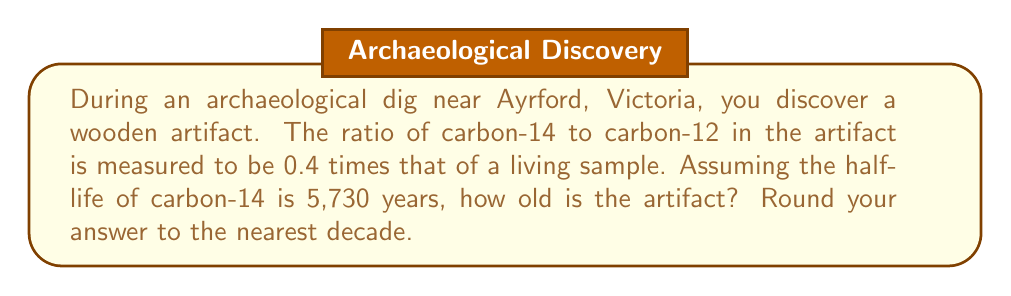Show me your answer to this math problem. Let's approach this step-by-step using the radiocarbon dating equation:

1) The equation for radiocarbon dating is:

   $$\frac{N}{N_0} = e^{-\lambda t}$$

   Where:
   $N$ = current amount of C-14
   $N_0$ = original amount of C-14
   $\lambda$ = decay constant
   $t$ = time elapsed

2) We're given that $\frac{N}{N_0} = 0.4$

3) We need to find $\lambda$. The half-life formula is:

   $$t_{1/2} = \frac{\ln(2)}{\lambda}$$

4) Rearranging for $\lambda$:

   $$\lambda = \frac{\ln(2)}{t_{1/2}} = \frac{\ln(2)}{5730} \approx 0.000121$$

5) Now we can solve for $t$:

   $$0.4 = e^{-0.000121t}$$

6) Taking the natural log of both sides:

   $$\ln(0.4) = -0.000121t$$

7) Solving for $t$:

   $$t = \frac{\ln(0.4)}{-0.000121} \approx 7565.7$$

8) Rounding to the nearest decade:

   $$t \approx 7570 \text{ years}$$
Answer: 7570 years 